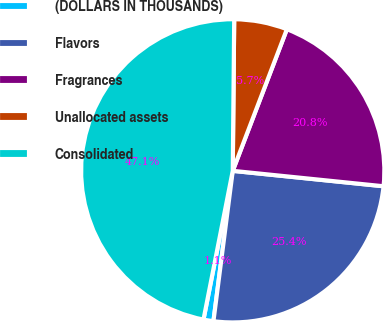Convert chart to OTSL. <chart><loc_0><loc_0><loc_500><loc_500><pie_chart><fcel>(DOLLARS IN THOUSANDS)<fcel>Flavors<fcel>Fragrances<fcel>Unallocated assets<fcel>Consolidated<nl><fcel>1.06%<fcel>25.41%<fcel>20.81%<fcel>5.66%<fcel>47.06%<nl></chart> 